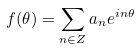<formula> <loc_0><loc_0><loc_500><loc_500>f ( \theta ) = \sum _ { n \in Z } a _ { n } e ^ { i n \theta }</formula> 